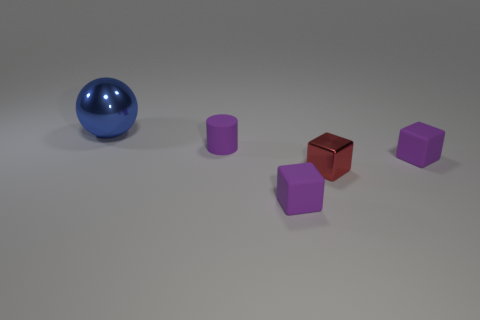Do the purple cylinder and the big sphere have the same material?
Make the answer very short. No. Is there a purple block made of the same material as the big blue object?
Your answer should be very brief. No. The small matte thing behind the purple block that is to the right of the tiny cube that is in front of the small red object is what color?
Your answer should be compact. Purple. What number of blue things are large metal spheres or small metal balls?
Your answer should be very brief. 1. How many other small red metallic objects have the same shape as the tiny metal thing?
Your answer should be compact. 0. There is a red metal thing that is the same size as the purple cylinder; what shape is it?
Keep it short and to the point. Cube. There is a small red object; are there any metal cubes behind it?
Your answer should be very brief. No. There is a purple rubber object that is in front of the red thing; is there a cube to the right of it?
Your answer should be very brief. Yes. Is the number of tiny red blocks that are behind the big blue metal thing less than the number of spheres that are on the left side of the red shiny thing?
Your response must be concise. Yes. Is there anything else that is the same size as the blue metallic sphere?
Offer a terse response. No. 